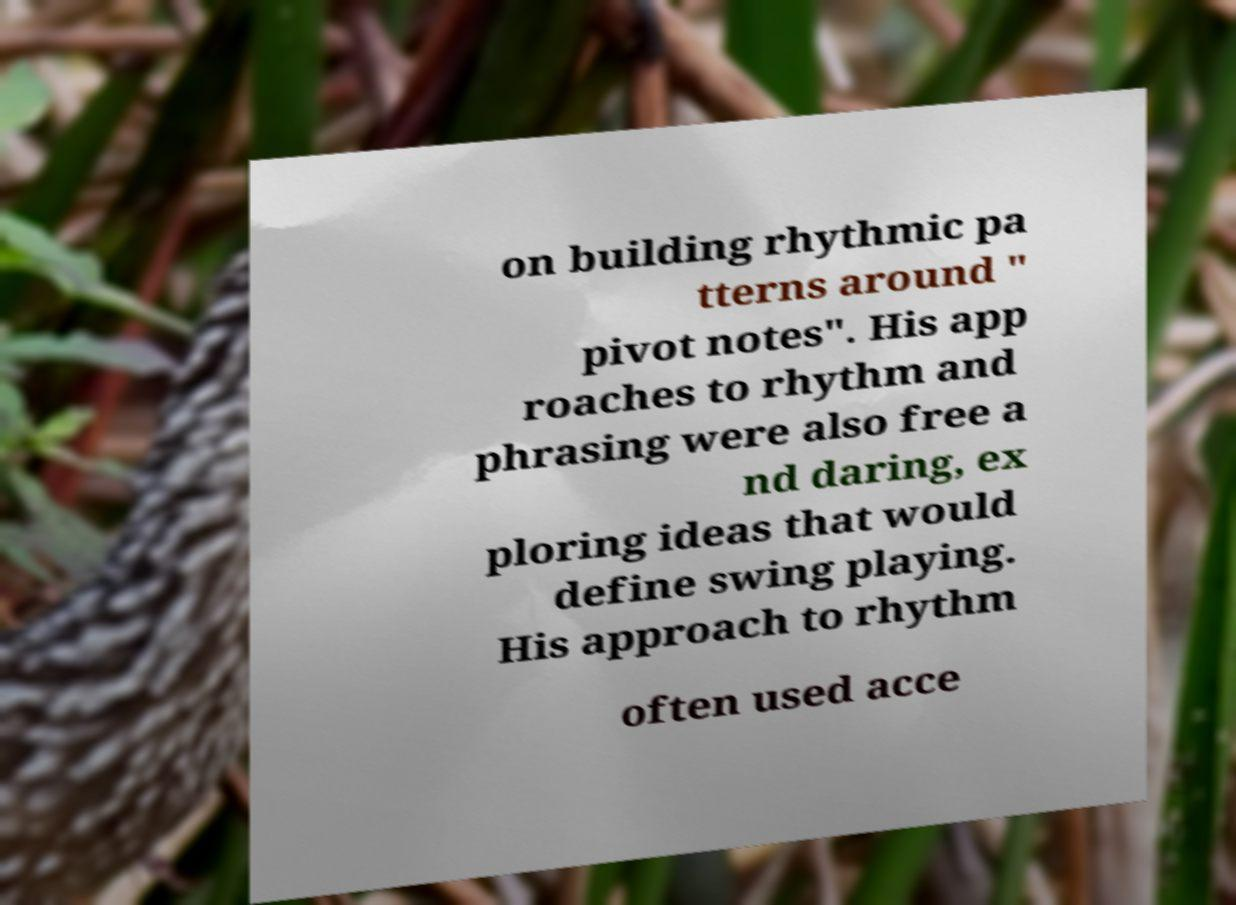Could you extract and type out the text from this image? on building rhythmic pa tterns around " pivot notes". His app roaches to rhythm and phrasing were also free a nd daring, ex ploring ideas that would define swing playing. His approach to rhythm often used acce 